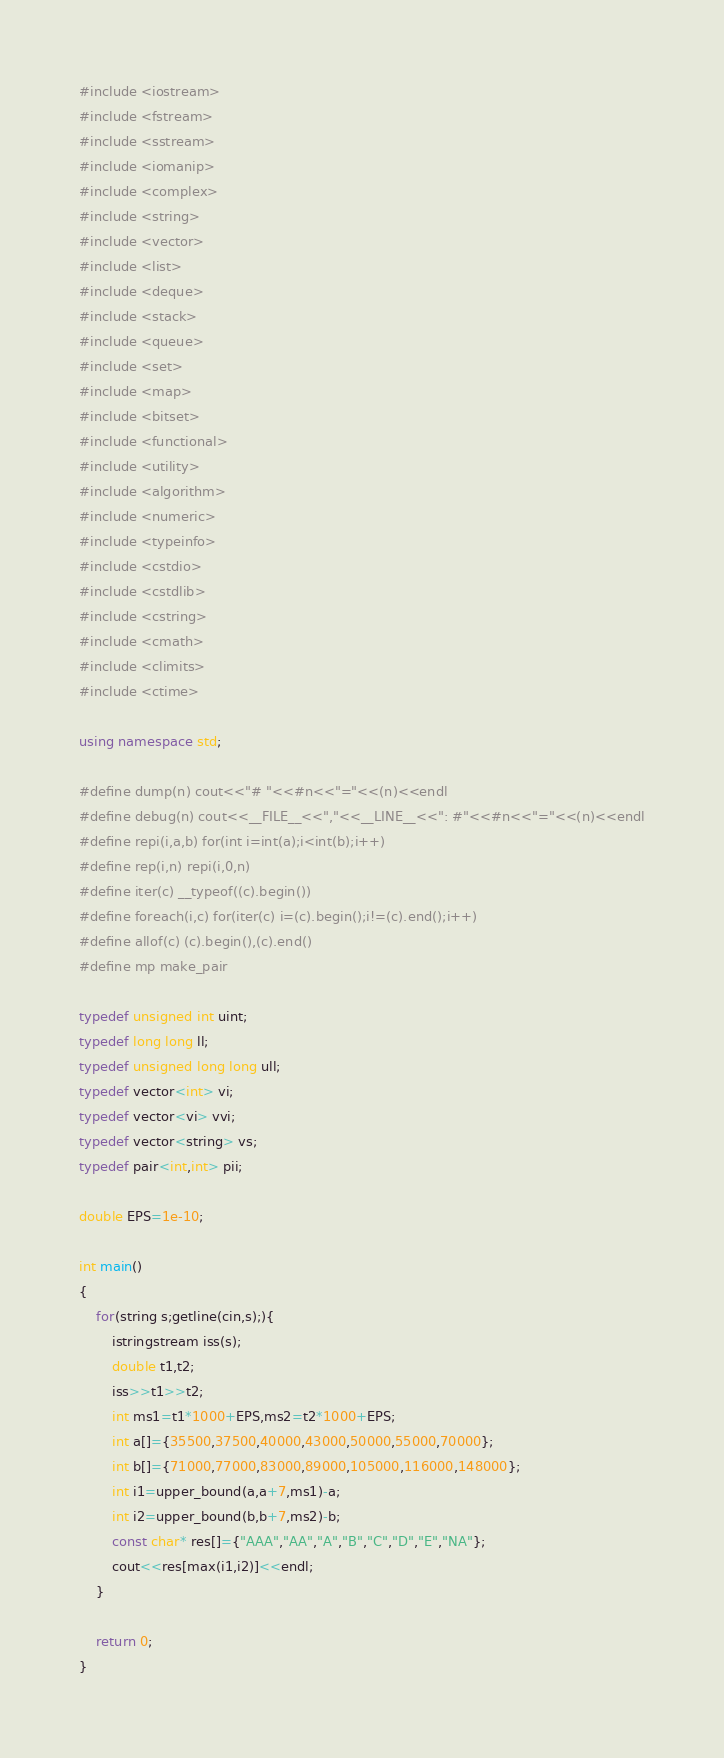<code> <loc_0><loc_0><loc_500><loc_500><_C++_>#include <iostream>
#include <fstream>
#include <sstream>
#include <iomanip>
#include <complex>
#include <string>
#include <vector>
#include <list>
#include <deque>
#include <stack>
#include <queue>
#include <set>
#include <map>
#include <bitset>
#include <functional>
#include <utility>
#include <algorithm>
#include <numeric>
#include <typeinfo>
#include <cstdio>
#include <cstdlib>
#include <cstring>
#include <cmath>
#include <climits>
#include <ctime>

using namespace std;

#define dump(n) cout<<"# "<<#n<<"="<<(n)<<endl
#define debug(n) cout<<__FILE__<<","<<__LINE__<<": #"<<#n<<"="<<(n)<<endl
#define repi(i,a,b) for(int i=int(a);i<int(b);i++)
#define rep(i,n) repi(i,0,n)
#define iter(c) __typeof((c).begin())
#define foreach(i,c) for(iter(c) i=(c).begin();i!=(c).end();i++)
#define allof(c) (c).begin(),(c).end()
#define mp make_pair

typedef unsigned int uint;
typedef long long ll;
typedef unsigned long long ull;
typedef vector<int> vi;
typedef vector<vi> vvi;
typedef vector<string> vs;
typedef pair<int,int> pii;

double EPS=1e-10;

int main()
{
	for(string s;getline(cin,s);){
		istringstream iss(s);
		double t1,t2;
		iss>>t1>>t2;
		int ms1=t1*1000+EPS,ms2=t2*1000+EPS;
		int a[]={35500,37500,40000,43000,50000,55000,70000};
		int b[]={71000,77000,83000,89000,105000,116000,148000};
		int i1=upper_bound(a,a+7,ms1)-a;
		int i2=upper_bound(b,b+7,ms2)-b;
		const char* res[]={"AAA","AA","A","B","C","D","E","NA"};
		cout<<res[max(i1,i2)]<<endl;
	}
	
	return 0;
}</code> 